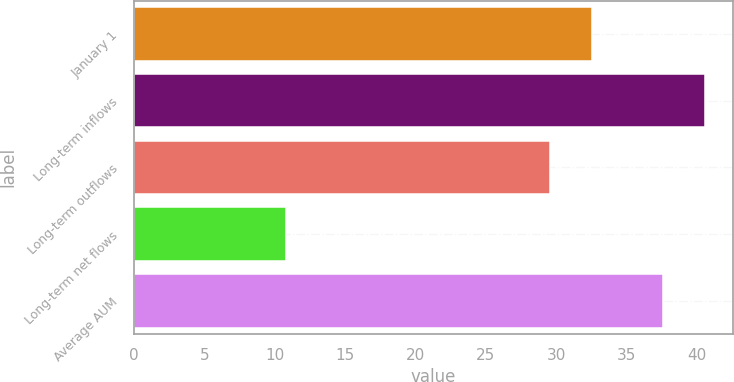<chart> <loc_0><loc_0><loc_500><loc_500><bar_chart><fcel>January 1<fcel>Long-term inflows<fcel>Long-term outflows<fcel>Long-term net flows<fcel>Average AUM<nl><fcel>32.56<fcel>40.56<fcel>29.6<fcel>10.8<fcel>37.6<nl></chart> 